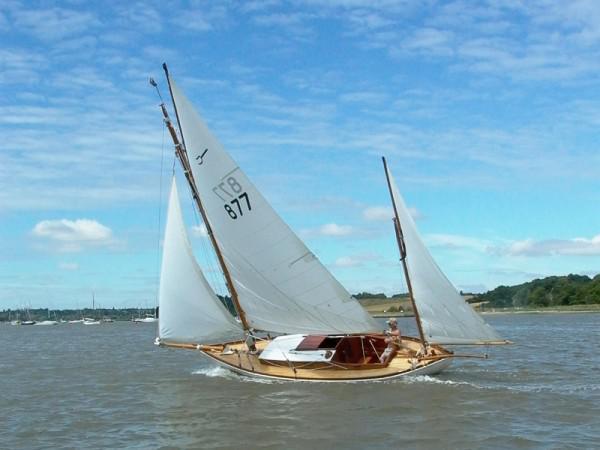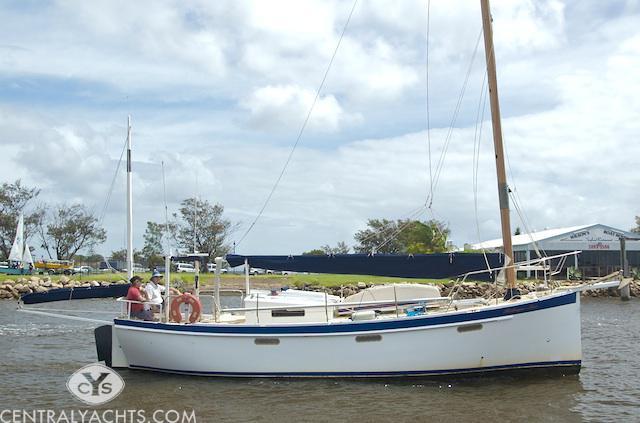The first image is the image on the left, the second image is the image on the right. Assess this claim about the two images: "There are three white sails in the image on the left.". Correct or not? Answer yes or no. Yes. The first image is the image on the left, the second image is the image on the right. Given the left and right images, does the statement "One of the images contains at least one sailboat with no raised sails." hold true? Answer yes or no. Yes. 